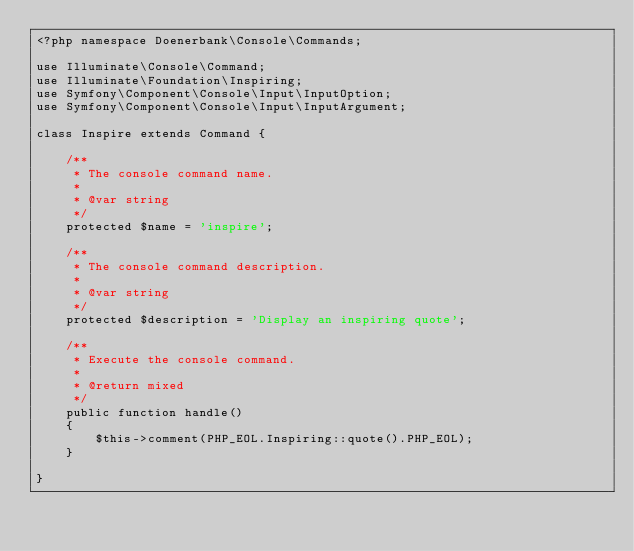<code> <loc_0><loc_0><loc_500><loc_500><_PHP_><?php namespace Doenerbank\Console\Commands;

use Illuminate\Console\Command;
use Illuminate\Foundation\Inspiring;
use Symfony\Component\Console\Input\InputOption;
use Symfony\Component\Console\Input\InputArgument;

class Inspire extends Command {

	/**
	 * The console command name.
	 *
	 * @var string
	 */
	protected $name = 'inspire';

	/**
	 * The console command description.
	 *
	 * @var string
	 */
	protected $description = 'Display an inspiring quote';

	/**
	 * Execute the console command.
	 *
	 * @return mixed
	 */
	public function handle()
	{
		$this->comment(PHP_EOL.Inspiring::quote().PHP_EOL);
	}

}
</code> 